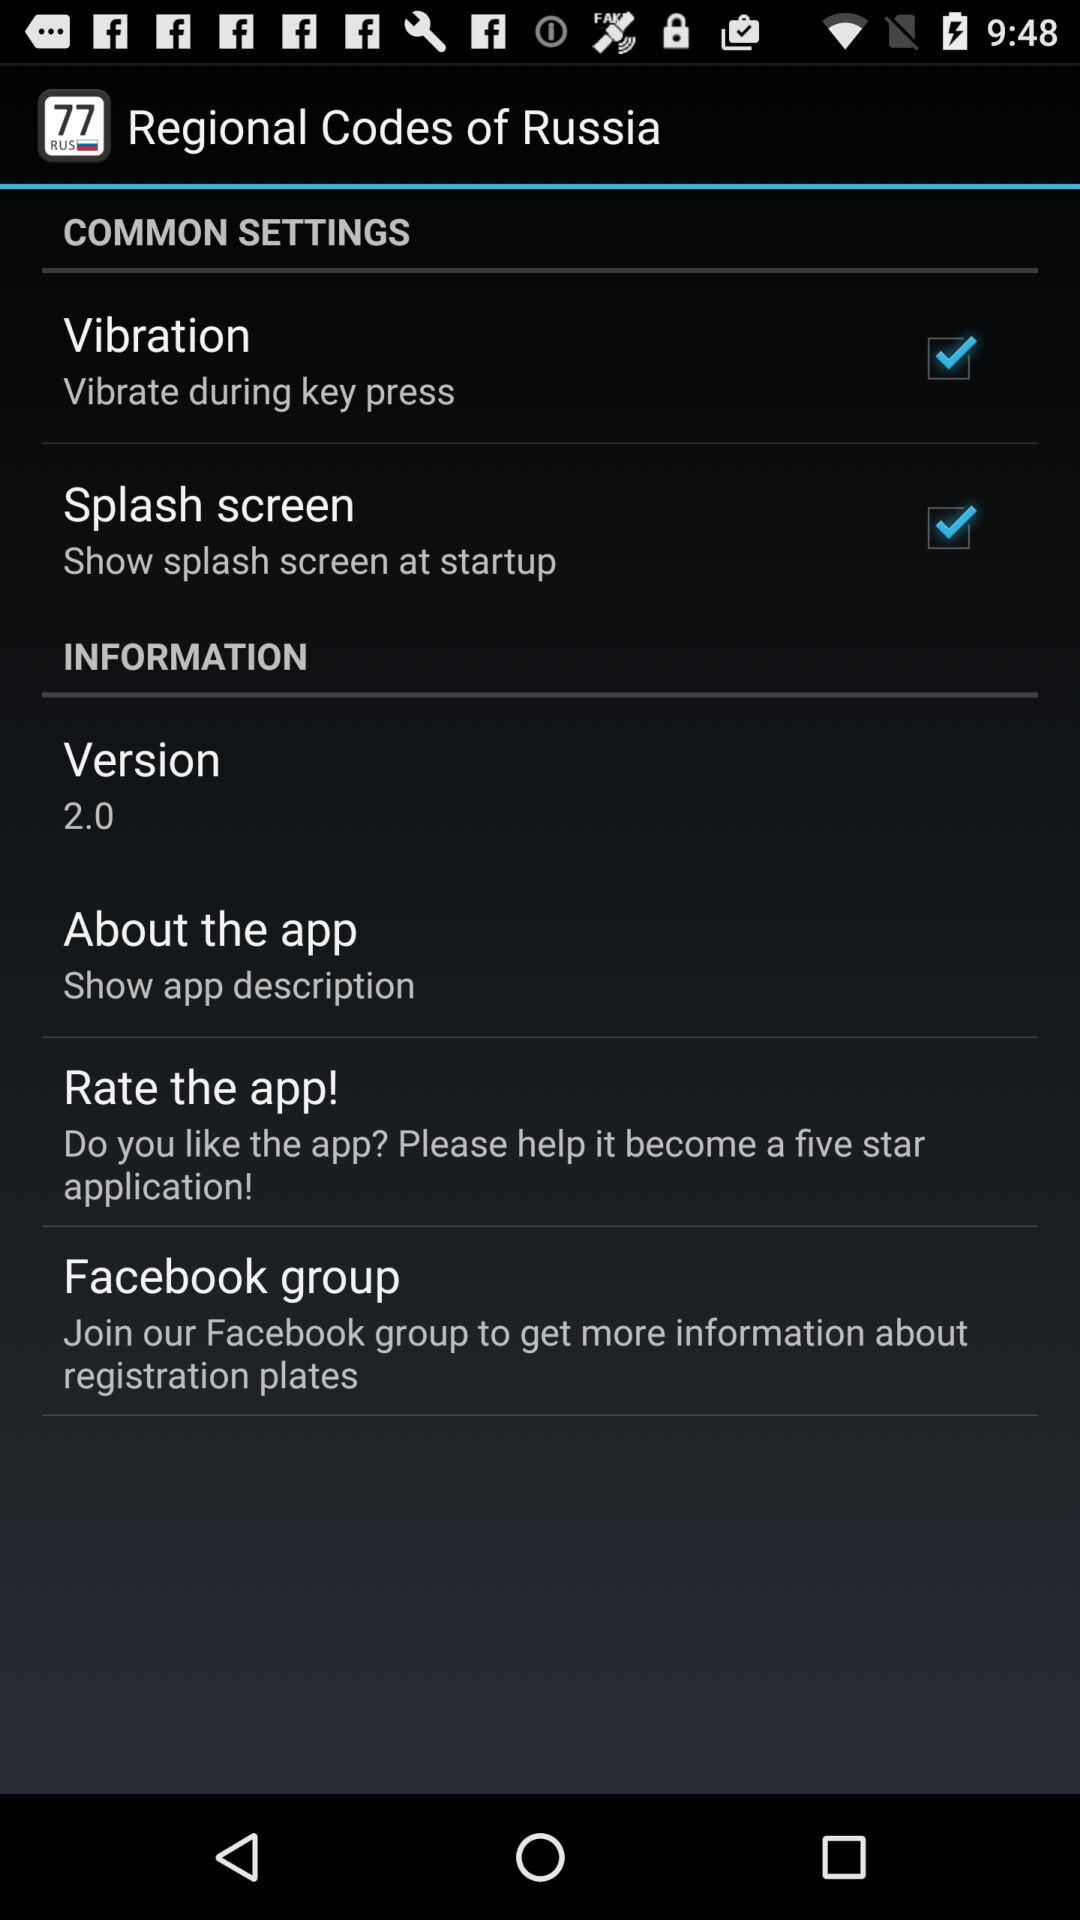What is the status of "Vibration"? The status is "on". 